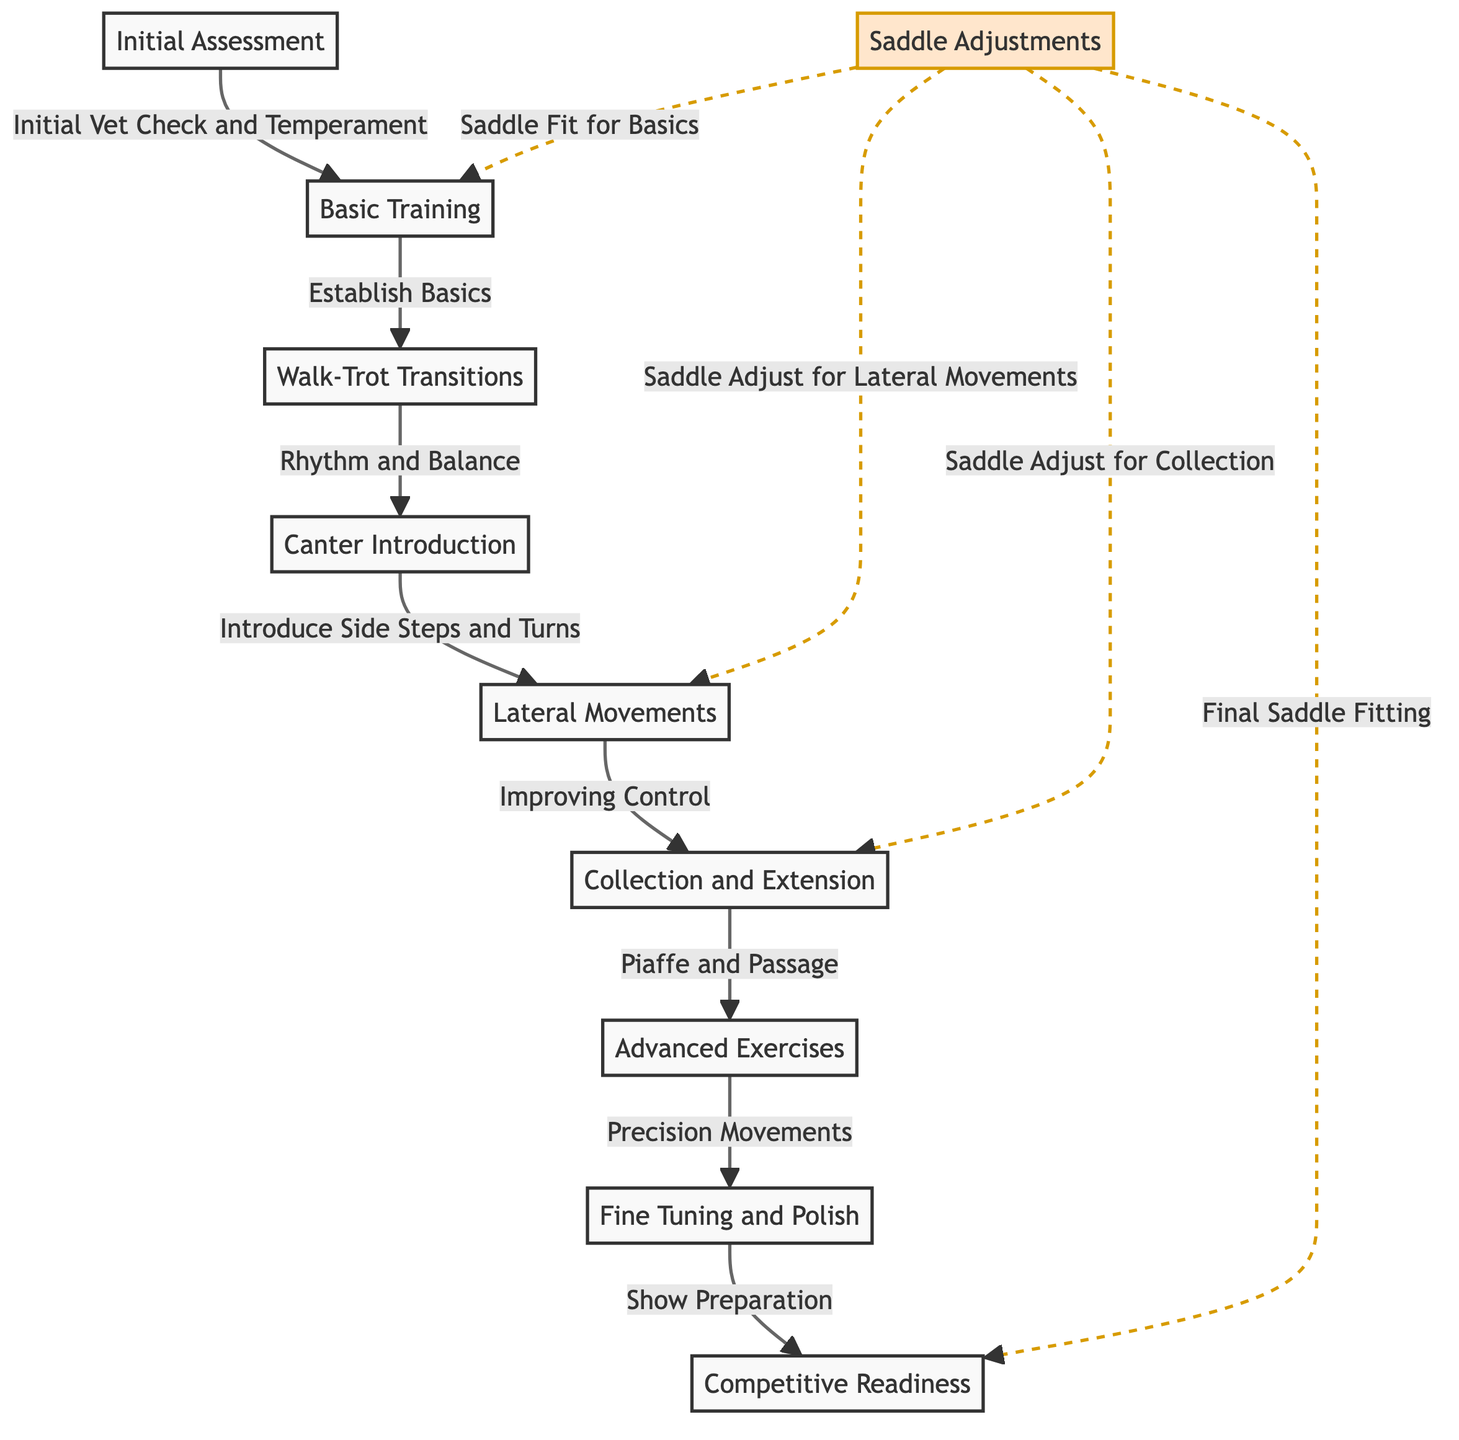What is the first step in the training progression? The diagram indicates that the first step is labeled as "Initial Assessment." This is the starting point from which all subsequent training actions flow.
Answer: Initial Assessment How many main training steps are there from Basic to Advanced Movements? By counting the main steps in the diagram, there are a total of eight primary training steps, ranging from Initial Assessment to Competitive Readiness.
Answer: Eight What is the relationship between Basic Training and Walk-Trot Transitions? The diagram shows a direct progression from "Basic Training" to "Walk-Trot Transitions," indicating that mastering the basics leads to this specific transition exercise.
Answer: Progression What adjustments are made for Lateral Movements? According to the diagram, saddle adjustments are specifically noted for lateral movements as part of the training process, indicating that the saddle fit needs to accommodate this type of training.
Answer: Saddle Adjust for Lateral Movements How many total adjustments are mentioned for the saddle throughout the training process? The diagram shows that there are four distinct saddle adjustments noted throughout the progression: one for the basics, one for lateral movements, one for collection, and one for final fitting.
Answer: Four What is the last step in the training timeline? The final step indicated in the training progression is "Competitive Readiness," which signifies the horse's preparedness for competition-level performance.
Answer: Competitive Readiness Which step comes after Collection and Extension? The diagram indicates that the next step following "Collection and Extension" is "Advanced Exercises," showing a sequential order in the training process.
Answer: Advanced Exercises What are the two movements introduced after Canter Introduction? According to the diagram, the two lateral movements introduced after "Canter Introduction" are "Lateral Movements" and "Collection and Extension."
Answer: Lateral Movements and Collection What does “Fine Tuning and Polish” focus on? The diagram shows that this step focuses on achieving "Precision Movements," which is essential for refinement at advanced levels of dressage training.
Answer: Precision Movements 